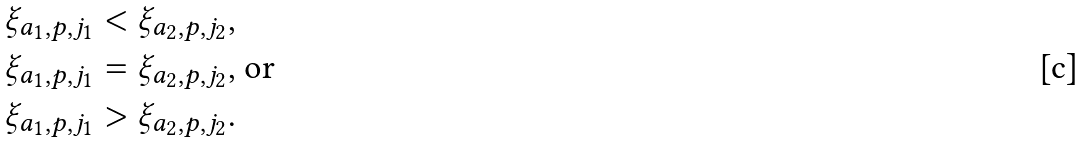<formula> <loc_0><loc_0><loc_500><loc_500>\xi _ { a _ { 1 } , p , j _ { 1 } } & < \xi _ { a _ { 2 } , p , j _ { 2 } } , \\ \xi _ { a _ { 1 } , p , j _ { 1 } } & = \xi _ { a _ { 2 } , p , j _ { 2 } } \text {, or} \\ \xi _ { a _ { 1 } , p , j _ { 1 } } & > \xi _ { a _ { 2 } , p , j _ { 2 } } .</formula> 